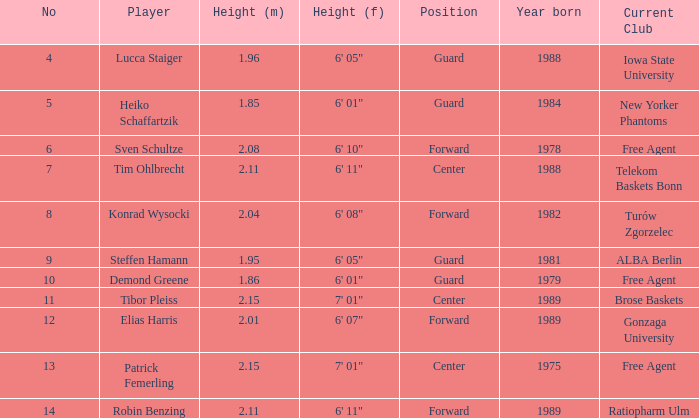Name the height for the player born 1989 and height 2.11 6' 11". 